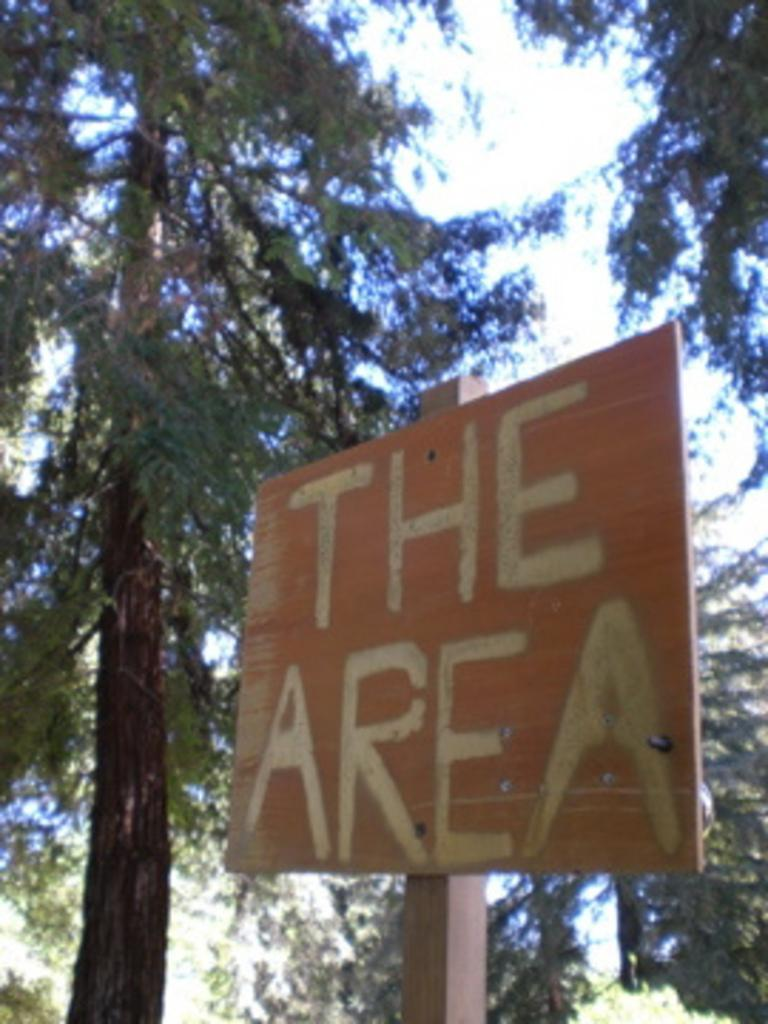What type of display board is in the image? There is a wooden display board in the image. What can be seen on the display board? The display board has text on it. What is visible in the background of the image? There are trees visible behind the display board. What type of plantation is visible behind the display board in the image? There is no plantation visible in the image; only trees are visible in the background of the image. What degree of comfort can be observed in the image? The image does not provide information about the comfort level of any objects or people in the scene. 